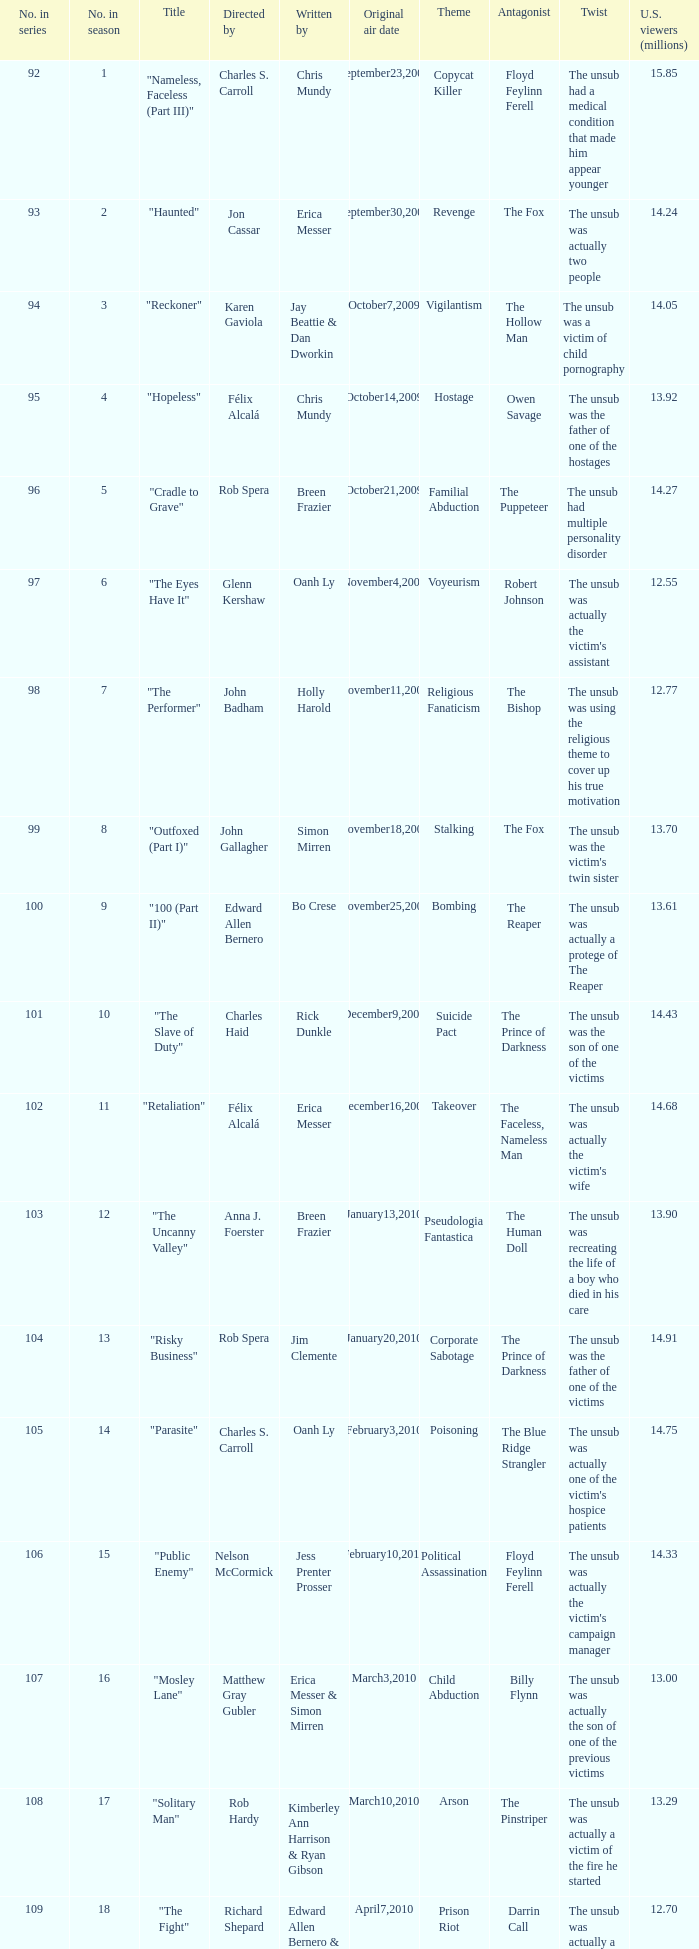Who wrote episode number 109 in the series? Edward Allen Bernero & Chris Mundy. 